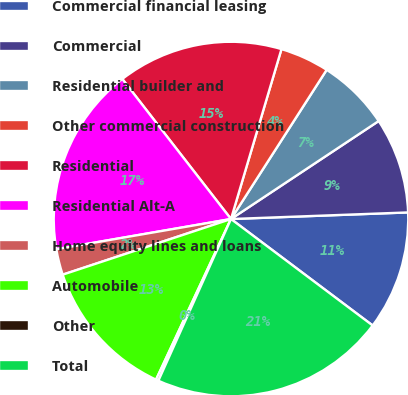Convert chart to OTSL. <chart><loc_0><loc_0><loc_500><loc_500><pie_chart><fcel>Commercial financial leasing<fcel>Commercial<fcel>Residential builder and<fcel>Other commercial construction<fcel>Residential<fcel>Residential Alt-A<fcel>Home equity lines and loans<fcel>Automobile<fcel>Other<fcel>Total<nl><fcel>10.85%<fcel>8.73%<fcel>6.6%<fcel>4.48%<fcel>15.1%<fcel>17.22%<fcel>2.36%<fcel>12.97%<fcel>0.23%<fcel>21.46%<nl></chart> 